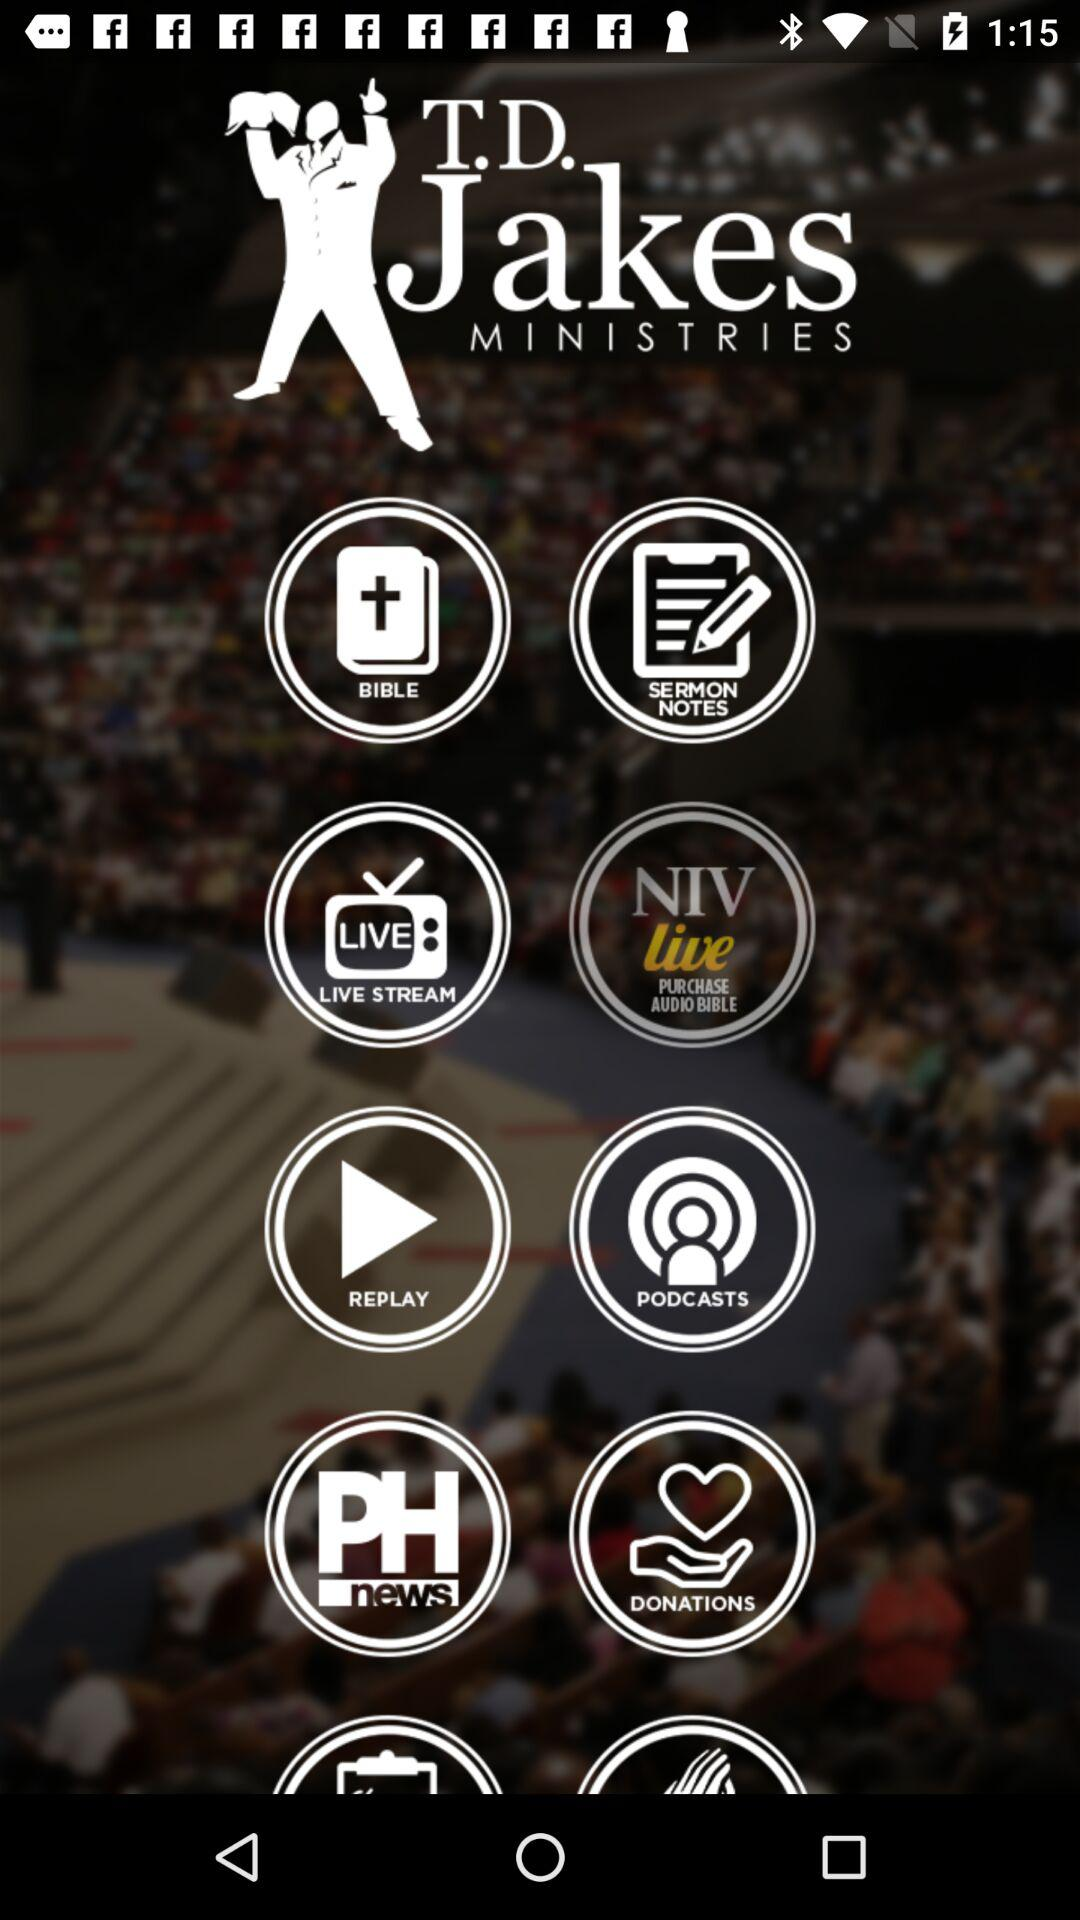What is the application name? The name of the application is "T.D. Jakes MINISTRIES". 